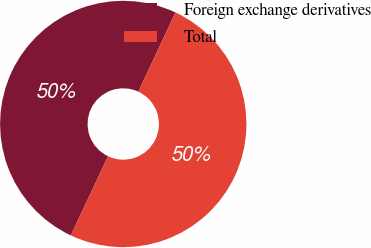<chart> <loc_0><loc_0><loc_500><loc_500><pie_chart><fcel>Foreign exchange derivatives<fcel>Total<nl><fcel>49.97%<fcel>50.03%<nl></chart> 